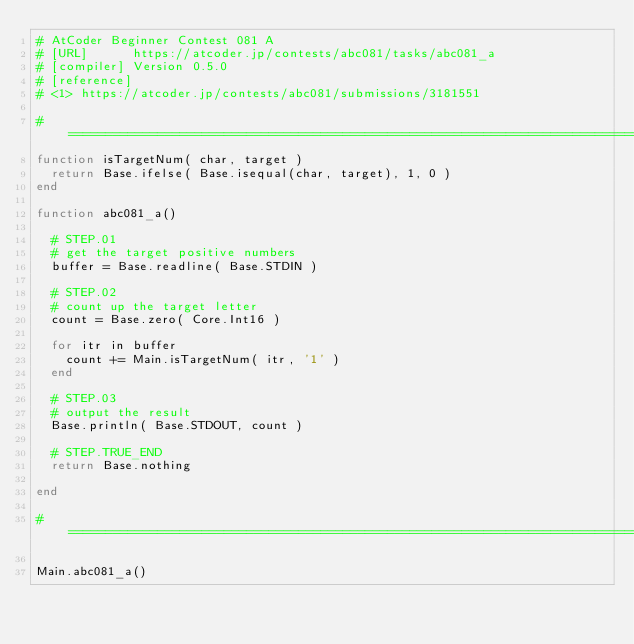Convert code to text. <code><loc_0><loc_0><loc_500><loc_500><_Julia_># AtCoder Beginner Contest 081 A
# [URL]      https://atcoder.jp/contests/abc081/tasks/abc081_a
# [compiler] Version 0.5.0
# [reference]
# <1> https://atcoder.jp/contests/abc081/submissions/3181551

#==================================================================================================#
function isTargetNum( char, target )
	return Base.ifelse( Base.isequal(char, target), 1, 0 )
end

function abc081_a()

	# STEP.01
	# get the target positive numbers
	buffer = Base.readline( Base.STDIN )

	# STEP.02
	# count up the target letter
	count = Base.zero( Core.Int16 )

	for itr in buffer
		count += Main.isTargetNum( itr, '1' )
	end

	# STEP.03
	# output the result
	Base.println( Base.STDOUT, count )

	# STEP.TRUE_END
	return Base.nothing

end

#==================================================================================================#

Main.abc081_a()
</code> 